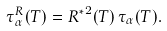Convert formula to latex. <formula><loc_0><loc_0><loc_500><loc_500>\tau ^ { R } _ { \alpha } ( T ) = { R ^ { * } } ^ { 2 } ( T ) \, \tau _ { \alpha } ( T ) .</formula> 